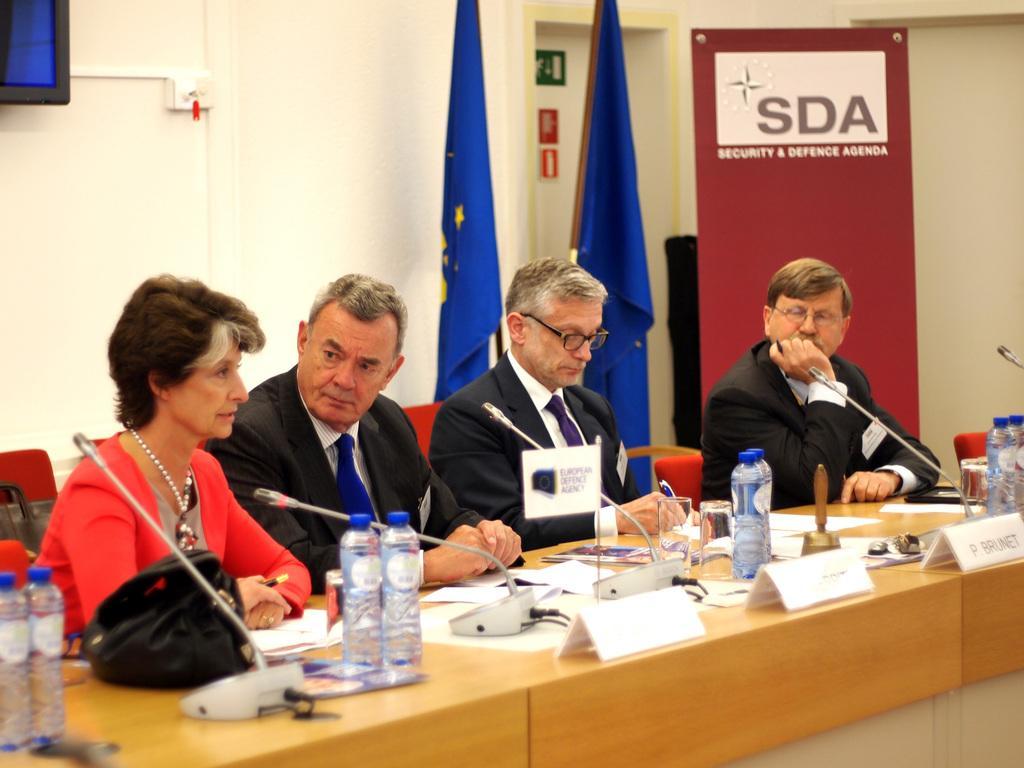Can you describe this image briefly? In this image we can see four persons sitting on the chairs. Here we can see three men wearing a suit and a tie. Here we can see a woman on the left side and she is speaking. Here we can see the wooden table. Here we can see the name plate boards, microphones and water bottles on the table. Here we can see the flags. Here we can see a television on the wall on the top left side. 